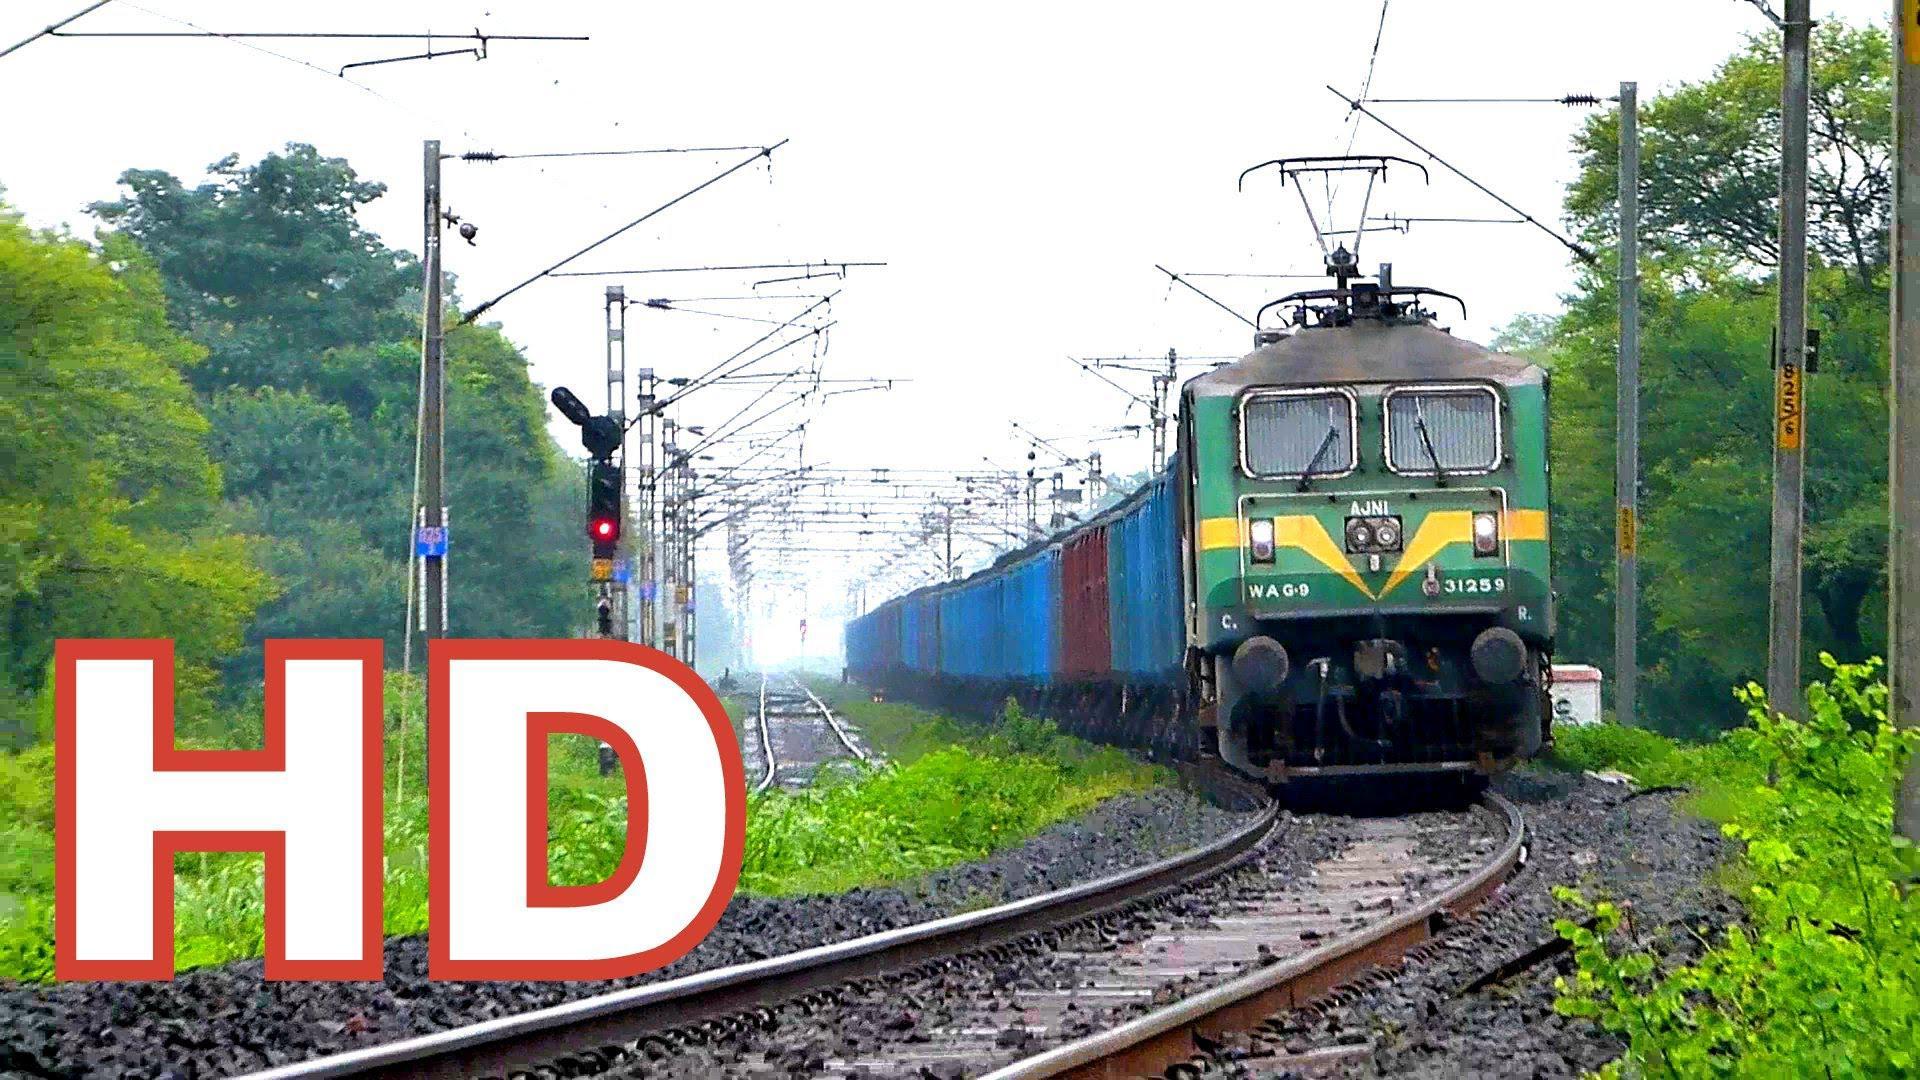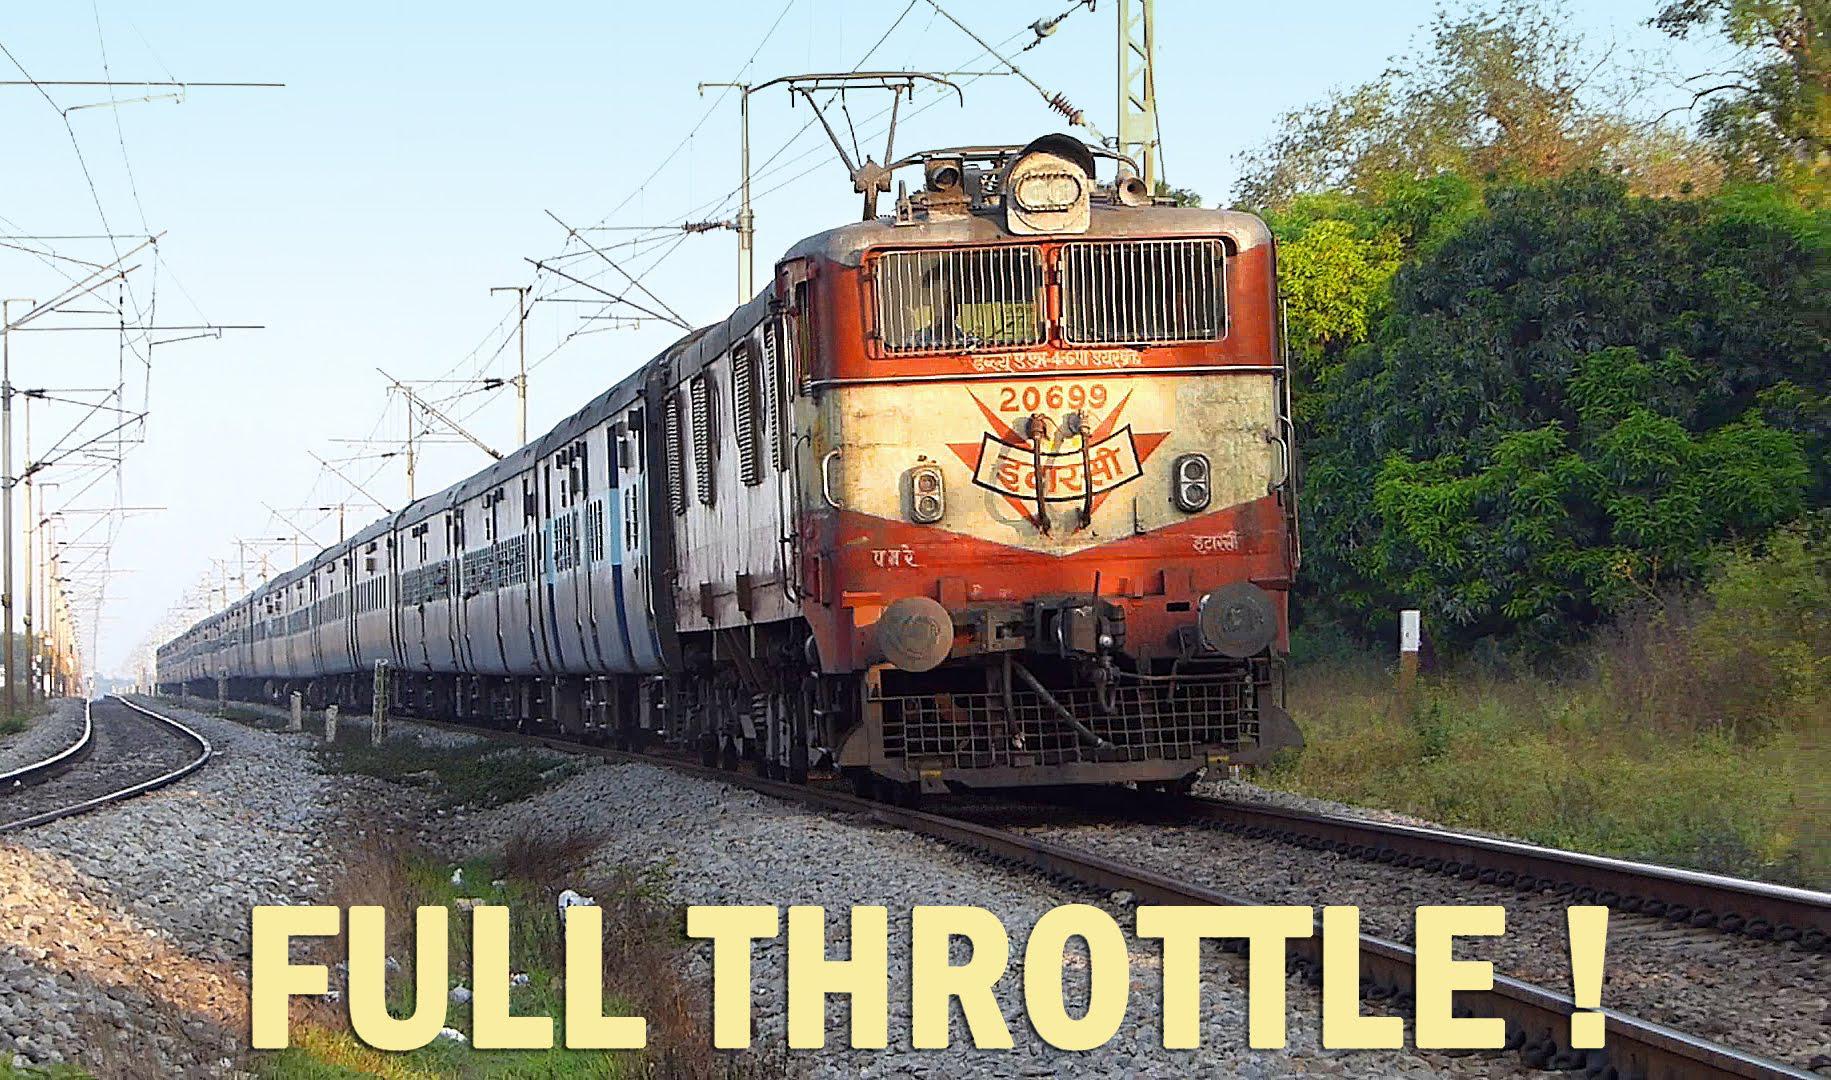The first image is the image on the left, the second image is the image on the right. Evaluate the accuracy of this statement regarding the images: "The train in the image on the right has grates covering its front windows.". Is it true? Answer yes or no. Yes. 